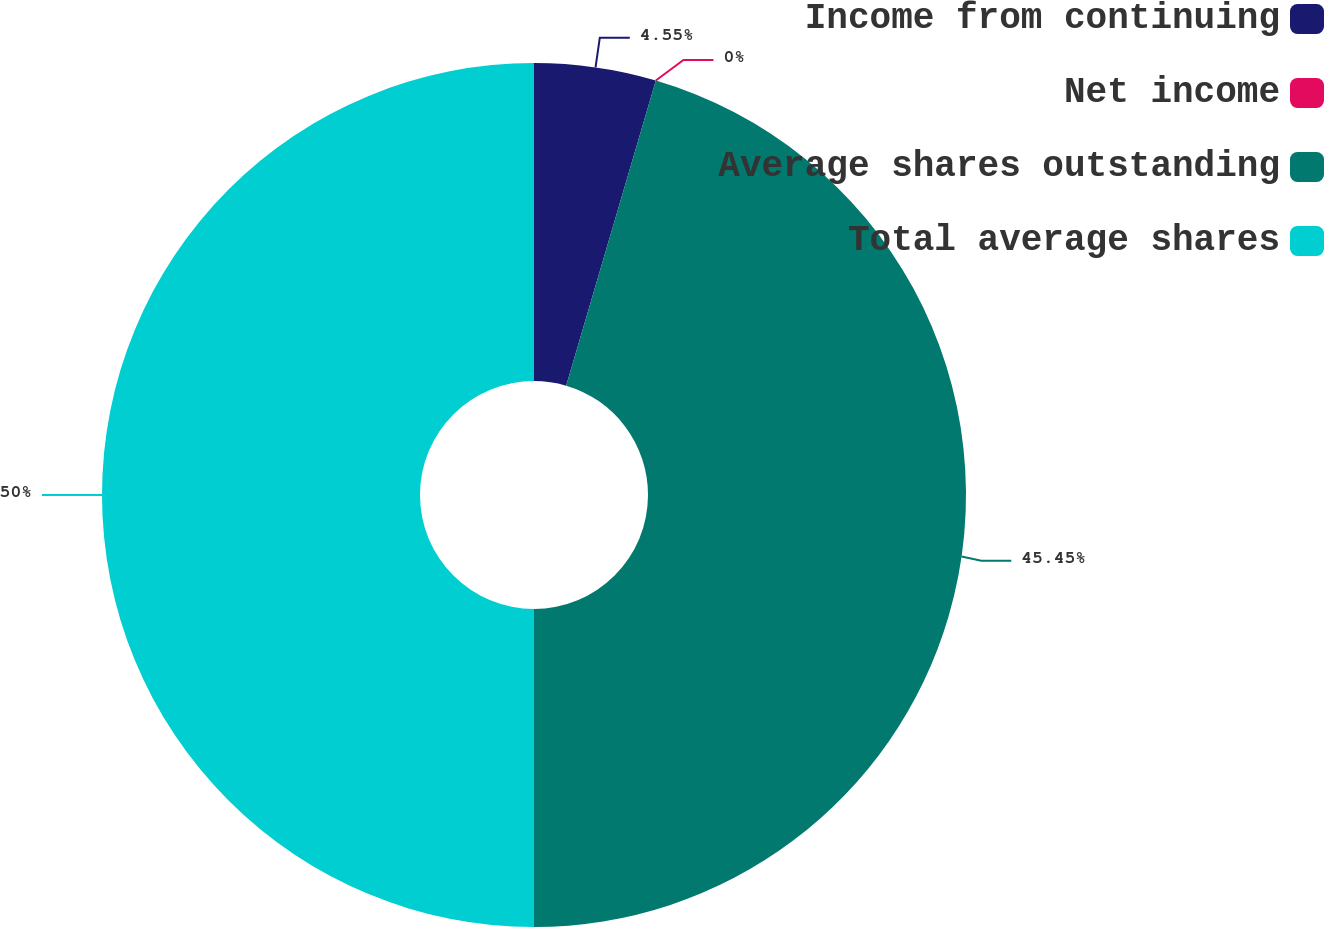Convert chart to OTSL. <chart><loc_0><loc_0><loc_500><loc_500><pie_chart><fcel>Income from continuing<fcel>Net income<fcel>Average shares outstanding<fcel>Total average shares<nl><fcel>4.55%<fcel>0.0%<fcel>45.45%<fcel>50.0%<nl></chart> 